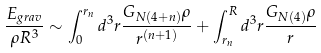Convert formula to latex. <formula><loc_0><loc_0><loc_500><loc_500>\frac { E _ { g r a v } } { \rho R ^ { 3 } } \sim \int _ { 0 } ^ { r _ { n } } d ^ { 3 } r \frac { G _ { N ( 4 + n ) } \rho } { r ^ { ( n + 1 ) } } + \int _ { r _ { n } } ^ { R } d ^ { 3 } r \frac { G _ { N ( 4 ) } \rho } { r }</formula> 